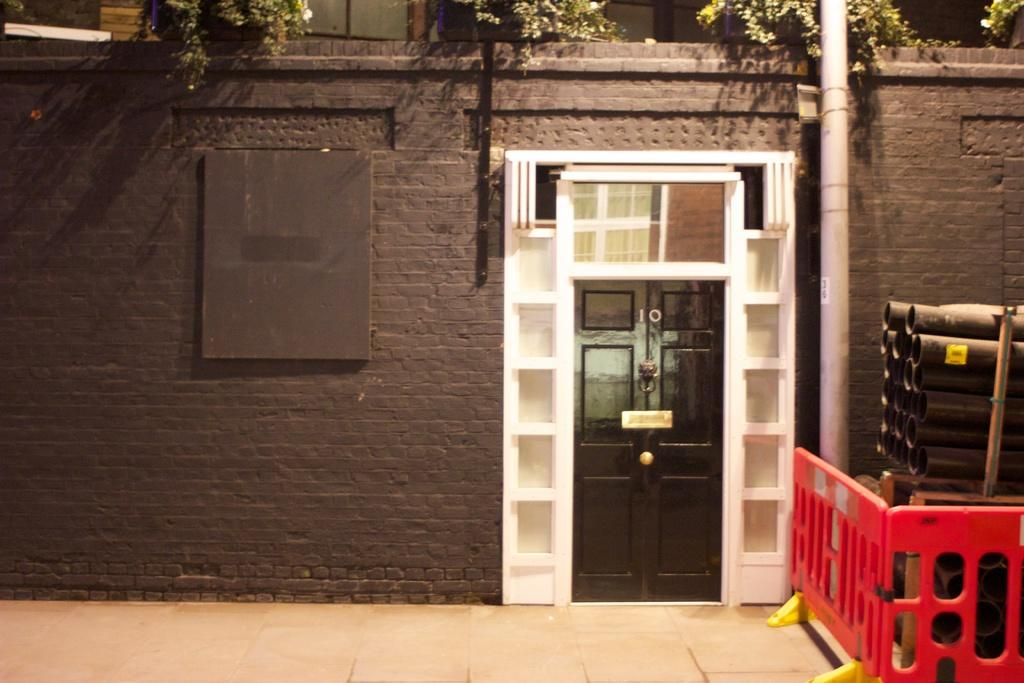What is a prominent feature in the image? There is a wall in the image. What is a functional element of the wall? There is a door in the wall. What can be seen to the right of the wall? There are pipes to the right of the wall. What type of vegetation is present on the wall? There are small plants at the top of the wall. Can you see an apple being kicked in the image? There is no apple or kicking action present in the image. 